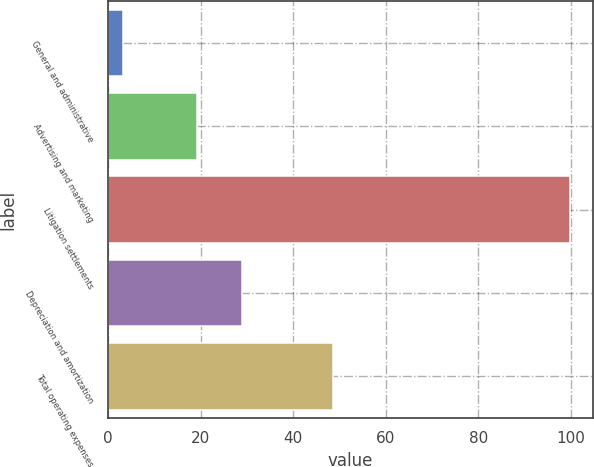Convert chart. <chart><loc_0><loc_0><loc_500><loc_500><bar_chart><fcel>General and administrative<fcel>Advertising and marketing<fcel>Litigation settlements<fcel>Depreciation and amortization<fcel>Total operating expenses<nl><fcel>3.1<fcel>19.2<fcel>99.7<fcel>28.86<fcel>48.6<nl></chart> 